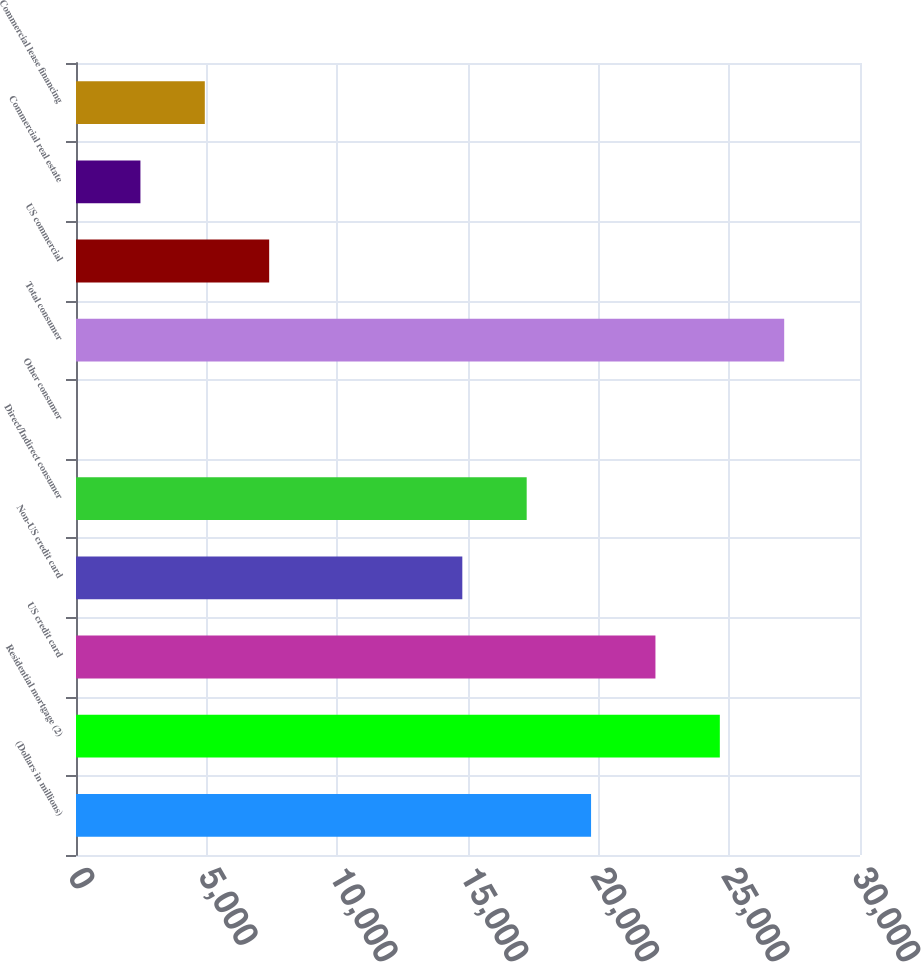Convert chart to OTSL. <chart><loc_0><loc_0><loc_500><loc_500><bar_chart><fcel>(Dollars in millions)<fcel>Residential mortgage (2)<fcel>US credit card<fcel>Non-US credit card<fcel>Direct/Indirect consumer<fcel>Other consumer<fcel>Total consumer<fcel>US commercial<fcel>Commercial real estate<fcel>Commercial lease financing<nl><fcel>19709.2<fcel>24636<fcel>22172.6<fcel>14782.4<fcel>17245.8<fcel>2<fcel>27099.4<fcel>7392.2<fcel>2465.4<fcel>4928.8<nl></chart> 